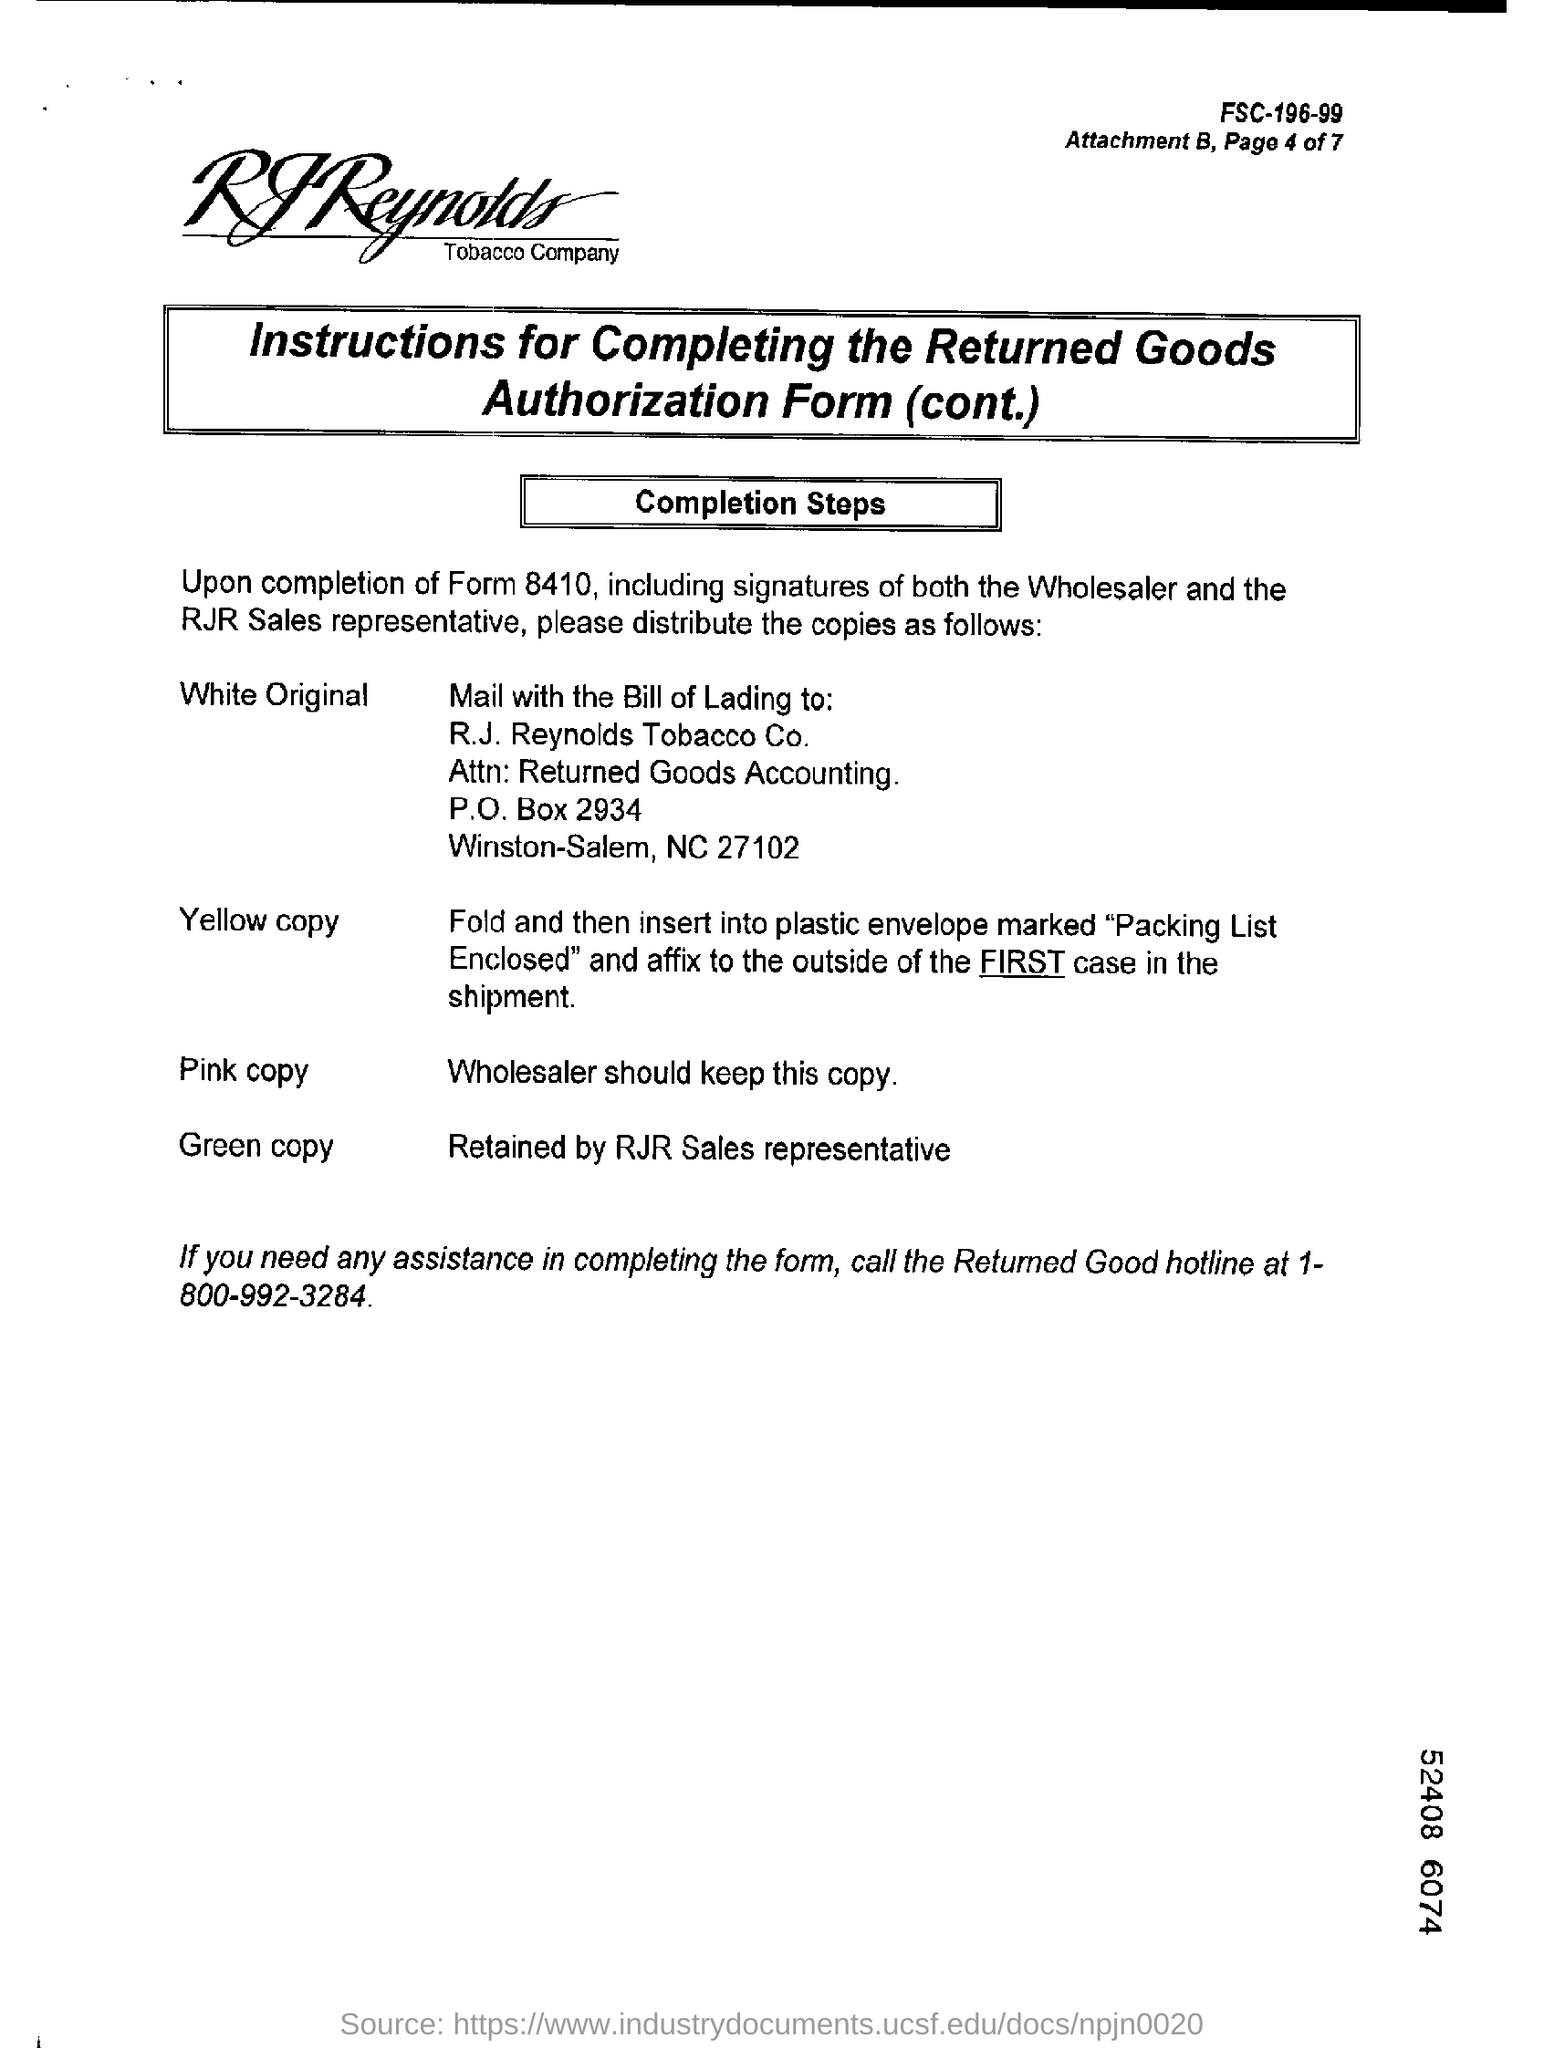Specify some key components in this picture. The returned goods hotline number is 1-800-992-3284. 